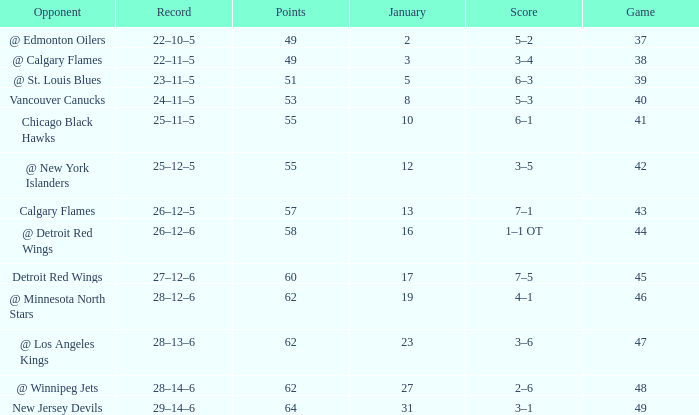Which Points have a Score of 4–1? 62.0. 